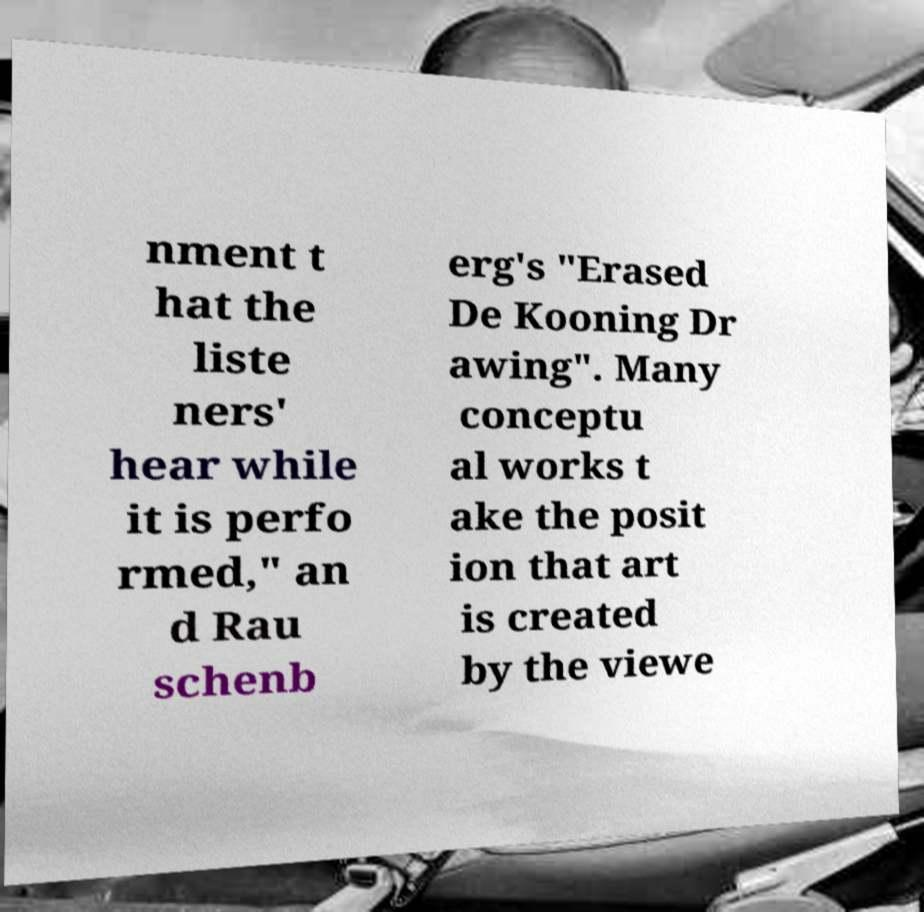For documentation purposes, I need the text within this image transcribed. Could you provide that? nment t hat the liste ners' hear while it is perfo rmed," an d Rau schenb erg's "Erased De Kooning Dr awing". Many conceptu al works t ake the posit ion that art is created by the viewe 